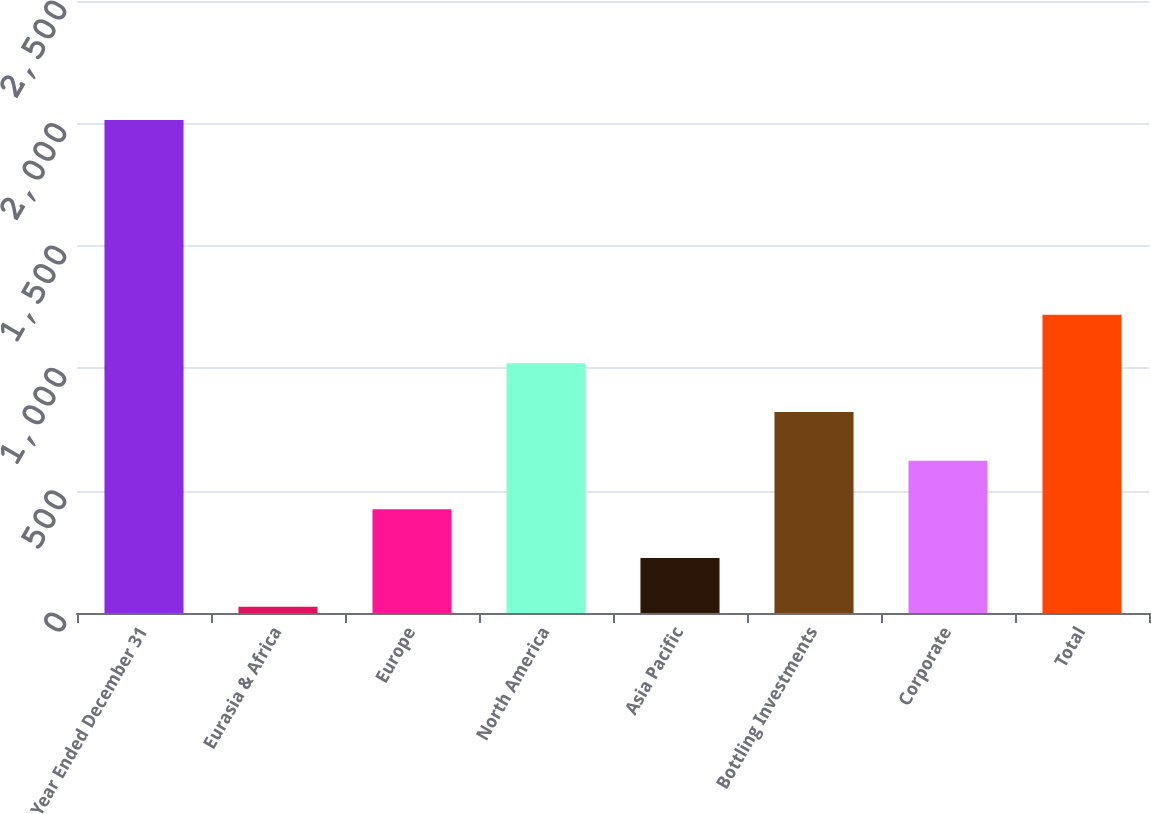<chart> <loc_0><loc_0><loc_500><loc_500><bar_chart><fcel>Year Ended December 31<fcel>Eurasia & Africa<fcel>Europe<fcel>North America<fcel>Asia Pacific<fcel>Bottling Investments<fcel>Corporate<fcel>Total<nl><fcel>2014<fcel>26<fcel>423.6<fcel>1020<fcel>224.8<fcel>821.2<fcel>622.4<fcel>1218.8<nl></chart> 